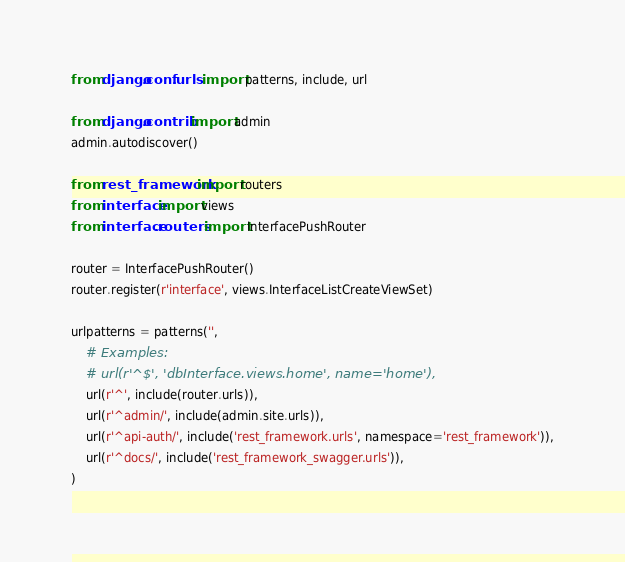<code> <loc_0><loc_0><loc_500><loc_500><_Python_>from django.conf.urls import patterns, include, url

from django.contrib import admin
admin.autodiscover()

from rest_framework import routers
from interface import views
from interface.routers import InterfacePushRouter

router = InterfacePushRouter()
router.register(r'interface', views.InterfaceListCreateViewSet)

urlpatterns = patterns('',
    # Examples:
    # url(r'^$', 'dbInterface.views.home', name='home'),
    url(r'^', include(router.urls)),
    url(r'^admin/', include(admin.site.urls)),
    url(r'^api-auth/', include('rest_framework.urls', namespace='rest_framework')),
    url(r'^docs/', include('rest_framework_swagger.urls')),
)
</code> 